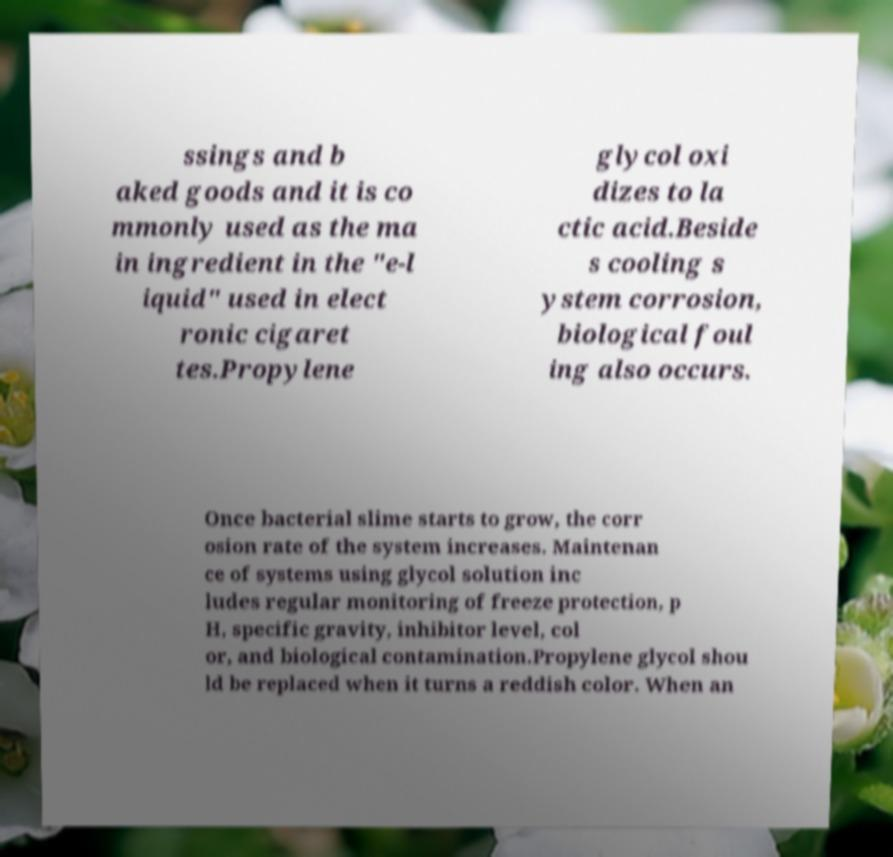For documentation purposes, I need the text within this image transcribed. Could you provide that? ssings and b aked goods and it is co mmonly used as the ma in ingredient in the "e-l iquid" used in elect ronic cigaret tes.Propylene glycol oxi dizes to la ctic acid.Beside s cooling s ystem corrosion, biological foul ing also occurs. Once bacterial slime starts to grow, the corr osion rate of the system increases. Maintenan ce of systems using glycol solution inc ludes regular monitoring of freeze protection, p H, specific gravity, inhibitor level, col or, and biological contamination.Propylene glycol shou ld be replaced when it turns a reddish color. When an 